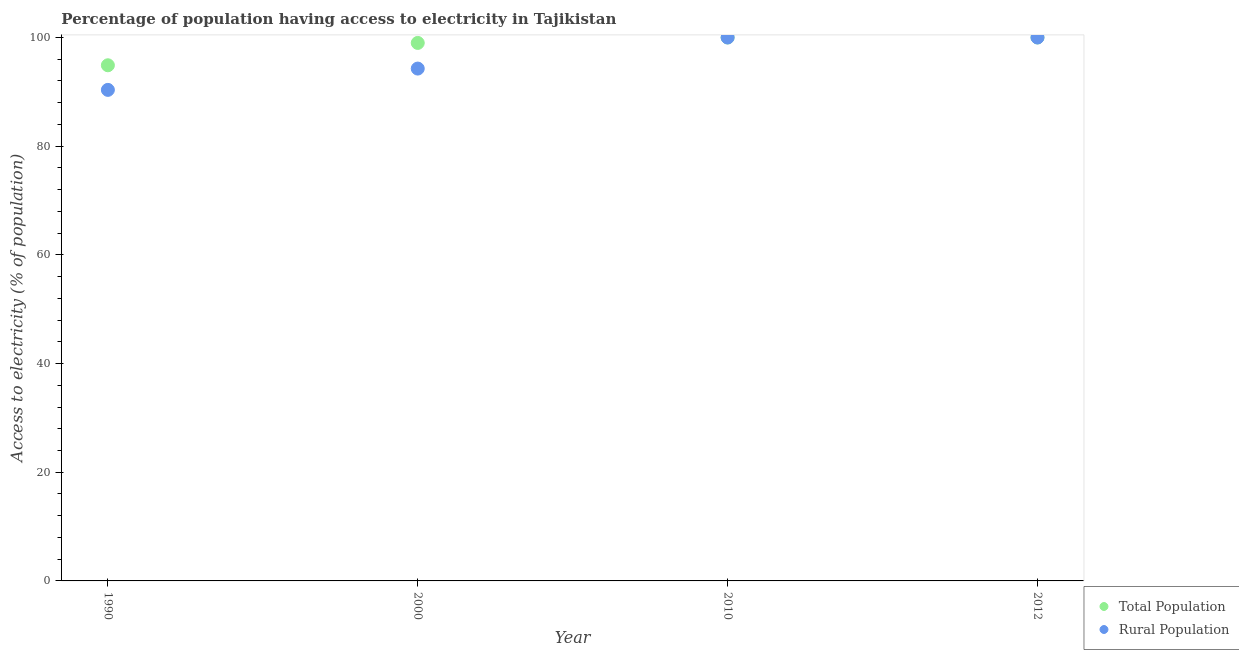How many different coloured dotlines are there?
Your answer should be compact. 2. Is the number of dotlines equal to the number of legend labels?
Ensure brevity in your answer.  Yes. Across all years, what is the minimum percentage of rural population having access to electricity?
Your answer should be very brief. 90.36. In which year was the percentage of rural population having access to electricity maximum?
Your answer should be very brief. 2010. In which year was the percentage of population having access to electricity minimum?
Provide a short and direct response. 1990. What is the total percentage of rural population having access to electricity in the graph?
Keep it short and to the point. 384.64. What is the difference between the percentage of rural population having access to electricity in 1990 and that in 2012?
Your answer should be compact. -9.64. What is the difference between the percentage of population having access to electricity in 2012 and the percentage of rural population having access to electricity in 2000?
Provide a short and direct response. 5.72. What is the average percentage of rural population having access to electricity per year?
Provide a succinct answer. 96.16. In the year 2000, what is the difference between the percentage of population having access to electricity and percentage of rural population having access to electricity?
Give a very brief answer. 4.72. In how many years, is the percentage of rural population having access to electricity greater than 84 %?
Provide a succinct answer. 4. What is the ratio of the percentage of rural population having access to electricity in 2010 to that in 2012?
Ensure brevity in your answer.  1. Is the difference between the percentage of rural population having access to electricity in 1990 and 2010 greater than the difference between the percentage of population having access to electricity in 1990 and 2010?
Your response must be concise. No. What is the difference between the highest and the lowest percentage of population having access to electricity?
Provide a short and direct response. 5.11. Does the percentage of population having access to electricity monotonically increase over the years?
Give a very brief answer. No. How many dotlines are there?
Offer a terse response. 2. Does the graph contain any zero values?
Your answer should be very brief. No. Where does the legend appear in the graph?
Your answer should be compact. Bottom right. How many legend labels are there?
Provide a short and direct response. 2. What is the title of the graph?
Keep it short and to the point. Percentage of population having access to electricity in Tajikistan. What is the label or title of the Y-axis?
Provide a short and direct response. Access to electricity (% of population). What is the Access to electricity (% of population) of Total Population in 1990?
Keep it short and to the point. 94.89. What is the Access to electricity (% of population) in Rural Population in 1990?
Keep it short and to the point. 90.36. What is the Access to electricity (% of population) in Total Population in 2000?
Give a very brief answer. 99. What is the Access to electricity (% of population) in Rural Population in 2000?
Your answer should be compact. 94.28. What is the Access to electricity (% of population) in Total Population in 2012?
Make the answer very short. 100. Across all years, what is the minimum Access to electricity (% of population) in Total Population?
Keep it short and to the point. 94.89. Across all years, what is the minimum Access to electricity (% of population) of Rural Population?
Your answer should be compact. 90.36. What is the total Access to electricity (% of population) of Total Population in the graph?
Provide a short and direct response. 393.89. What is the total Access to electricity (% of population) of Rural Population in the graph?
Offer a very short reply. 384.64. What is the difference between the Access to electricity (% of population) in Total Population in 1990 and that in 2000?
Provide a short and direct response. -4.11. What is the difference between the Access to electricity (% of population) of Rural Population in 1990 and that in 2000?
Your answer should be compact. -3.92. What is the difference between the Access to electricity (% of population) in Total Population in 1990 and that in 2010?
Make the answer very short. -5.11. What is the difference between the Access to electricity (% of population) in Rural Population in 1990 and that in 2010?
Offer a terse response. -9.64. What is the difference between the Access to electricity (% of population) in Total Population in 1990 and that in 2012?
Your response must be concise. -5.11. What is the difference between the Access to electricity (% of population) of Rural Population in 1990 and that in 2012?
Your answer should be compact. -9.64. What is the difference between the Access to electricity (% of population) in Rural Population in 2000 and that in 2010?
Provide a short and direct response. -5.72. What is the difference between the Access to electricity (% of population) of Rural Population in 2000 and that in 2012?
Make the answer very short. -5.72. What is the difference between the Access to electricity (% of population) of Rural Population in 2010 and that in 2012?
Ensure brevity in your answer.  0. What is the difference between the Access to electricity (% of population) of Total Population in 1990 and the Access to electricity (% of population) of Rural Population in 2000?
Your answer should be compact. 0.61. What is the difference between the Access to electricity (% of population) in Total Population in 1990 and the Access to electricity (% of population) in Rural Population in 2010?
Your response must be concise. -5.11. What is the difference between the Access to electricity (% of population) of Total Population in 1990 and the Access to electricity (% of population) of Rural Population in 2012?
Provide a succinct answer. -5.11. What is the difference between the Access to electricity (% of population) in Total Population in 2000 and the Access to electricity (% of population) in Rural Population in 2012?
Make the answer very short. -1. What is the difference between the Access to electricity (% of population) of Total Population in 2010 and the Access to electricity (% of population) of Rural Population in 2012?
Provide a short and direct response. 0. What is the average Access to electricity (% of population) in Total Population per year?
Make the answer very short. 98.47. What is the average Access to electricity (% of population) of Rural Population per year?
Your answer should be very brief. 96.16. In the year 1990, what is the difference between the Access to electricity (% of population) of Total Population and Access to electricity (% of population) of Rural Population?
Offer a very short reply. 4.53. In the year 2000, what is the difference between the Access to electricity (% of population) in Total Population and Access to electricity (% of population) in Rural Population?
Provide a short and direct response. 4.72. In the year 2010, what is the difference between the Access to electricity (% of population) of Total Population and Access to electricity (% of population) of Rural Population?
Give a very brief answer. 0. What is the ratio of the Access to electricity (% of population) in Total Population in 1990 to that in 2000?
Your answer should be compact. 0.96. What is the ratio of the Access to electricity (% of population) of Rural Population in 1990 to that in 2000?
Give a very brief answer. 0.96. What is the ratio of the Access to electricity (% of population) in Total Population in 1990 to that in 2010?
Provide a succinct answer. 0.95. What is the ratio of the Access to electricity (% of population) in Rural Population in 1990 to that in 2010?
Your answer should be very brief. 0.9. What is the ratio of the Access to electricity (% of population) of Total Population in 1990 to that in 2012?
Provide a short and direct response. 0.95. What is the ratio of the Access to electricity (% of population) of Rural Population in 1990 to that in 2012?
Keep it short and to the point. 0.9. What is the ratio of the Access to electricity (% of population) of Total Population in 2000 to that in 2010?
Your response must be concise. 0.99. What is the ratio of the Access to electricity (% of population) of Rural Population in 2000 to that in 2010?
Keep it short and to the point. 0.94. What is the ratio of the Access to electricity (% of population) in Total Population in 2000 to that in 2012?
Your answer should be very brief. 0.99. What is the ratio of the Access to electricity (% of population) in Rural Population in 2000 to that in 2012?
Your answer should be compact. 0.94. What is the difference between the highest and the second highest Access to electricity (% of population) in Total Population?
Keep it short and to the point. 0. What is the difference between the highest and the second highest Access to electricity (% of population) in Rural Population?
Ensure brevity in your answer.  0. What is the difference between the highest and the lowest Access to electricity (% of population) in Total Population?
Offer a very short reply. 5.11. What is the difference between the highest and the lowest Access to electricity (% of population) in Rural Population?
Keep it short and to the point. 9.64. 